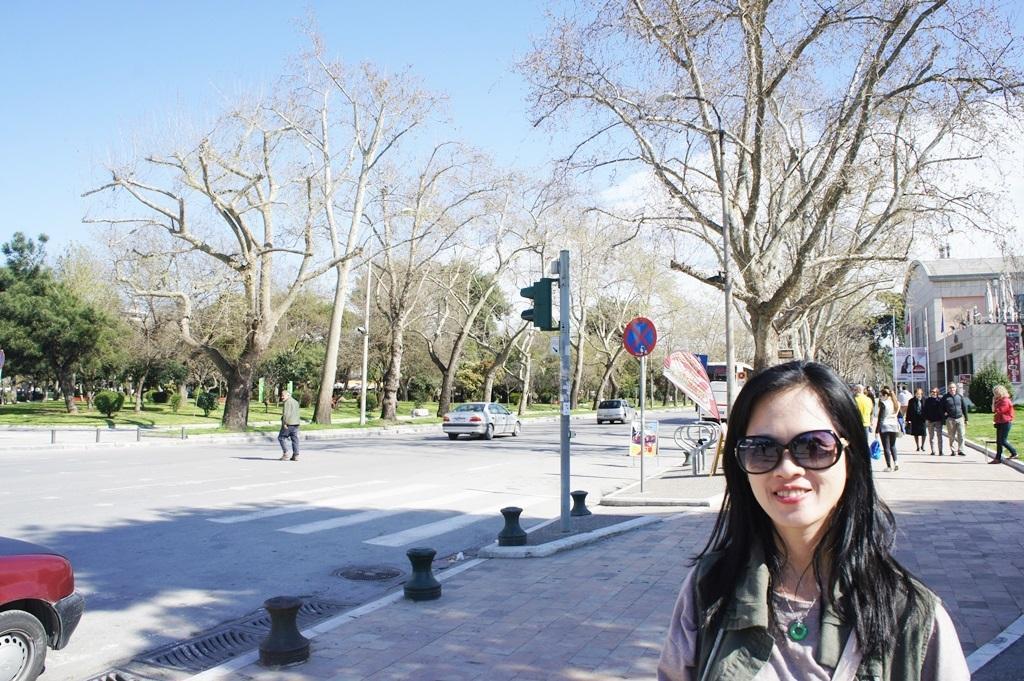How would you summarize this image in a sentence or two? In this image I can see a road , on the road I can see a person vehicle , pole sign board , traffic signal light and trees and divider blocks visible at the top I can see the sky and on the right side I can see building , in front of the building I can see persons walking and at the bottom I can see a woman she is smiling and she wearing a spectacle and on the left side I can see a red color vehicle. 